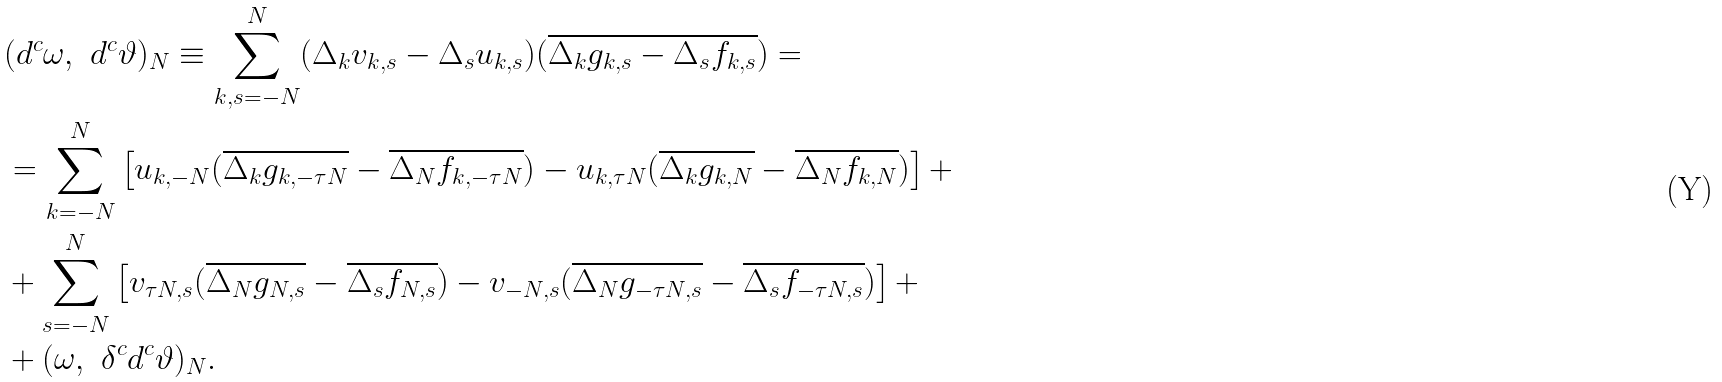<formula> <loc_0><loc_0><loc_500><loc_500>& ( d ^ { c } \omega , \ d ^ { c } \vartheta ) _ { N } \equiv \sum _ { k , s = - N } ^ { N } ( \Delta _ { k } v _ { k , s } - \Delta _ { s } u _ { k , s } ) ( \overline { \Delta _ { k } g _ { k , s } - \Delta _ { s } f _ { k , s } } ) = \\ & = \sum _ { k = - N } ^ { N } \left [ u _ { k , - N } ( \overline { \Delta _ { k } g _ { k , - \tau N } } - \overline { \Delta _ { N } f _ { k , - \tau N } } ) - u _ { k , \tau N } ( \overline { \Delta _ { k } g _ { k , N } } - \overline { \Delta _ { N } f _ { k , N } } ) \right ] + \\ & + \sum _ { s = - N } ^ { N } \left [ v _ { \tau N , s } ( \overline { \Delta _ { N } g _ { N , s } } - \overline { \Delta _ { s } f _ { N , s } } ) - v _ { - N , s } ( \overline { \Delta _ { N } g _ { - \tau N , s } } - \overline { \Delta _ { s } f _ { - \tau N , s } } ) \right ] + \\ & + ( \omega , \ \delta ^ { c } d ^ { c } \vartheta ) _ { N } .</formula> 